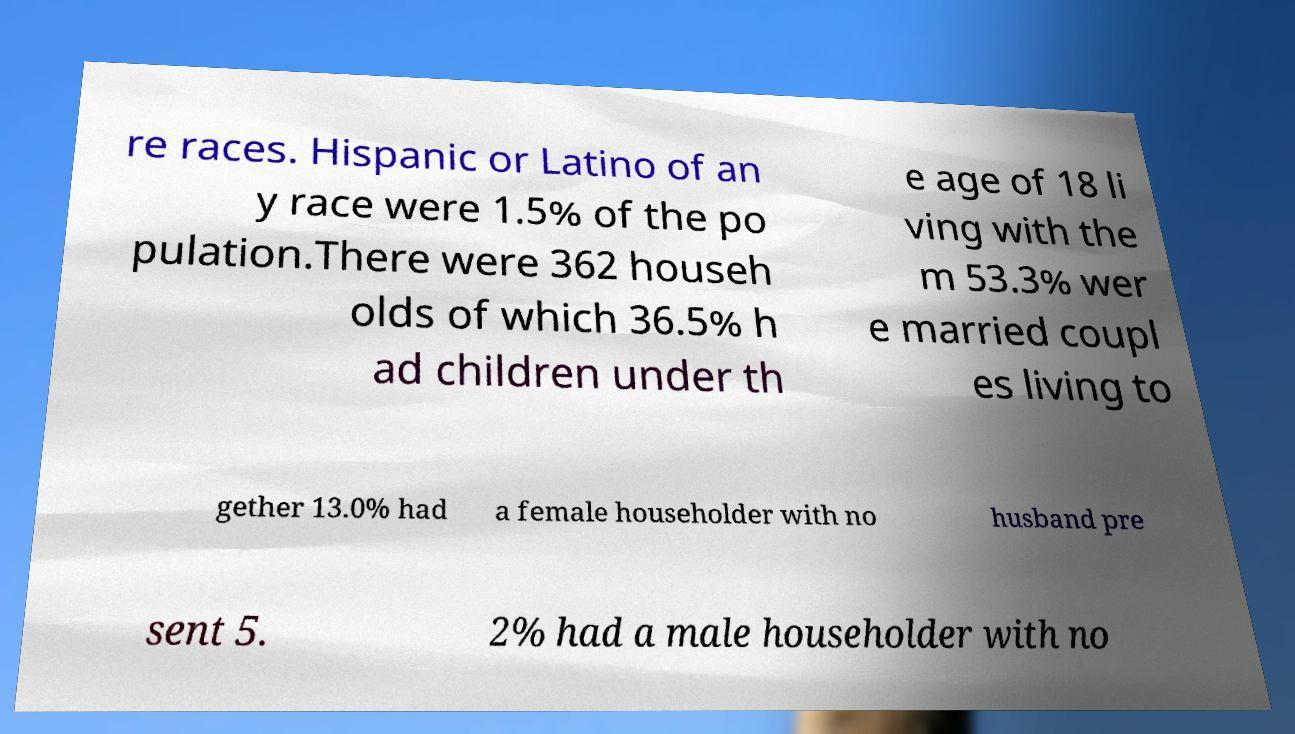What messages or text are displayed in this image? I need them in a readable, typed format. re races. Hispanic or Latino of an y race were 1.5% of the po pulation.There were 362 househ olds of which 36.5% h ad children under th e age of 18 li ving with the m 53.3% wer e married coupl es living to gether 13.0% had a female householder with no husband pre sent 5. 2% had a male householder with no 